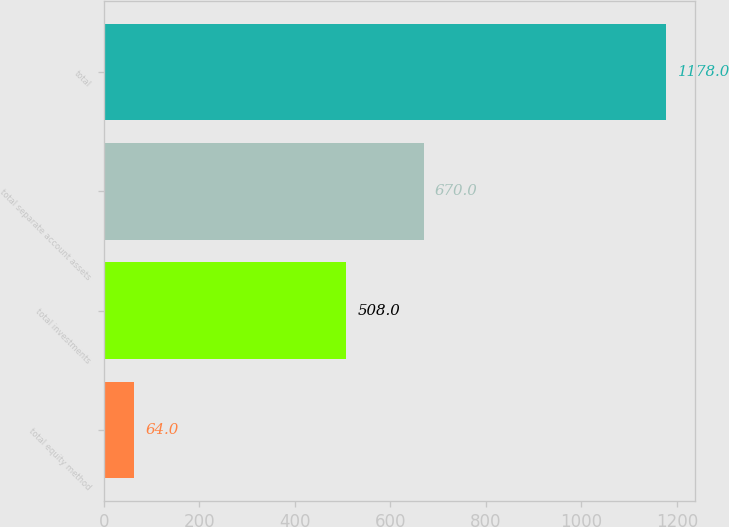<chart> <loc_0><loc_0><loc_500><loc_500><bar_chart><fcel>total equity method<fcel>total investments<fcel>total separate account assets<fcel>total<nl><fcel>64<fcel>508<fcel>670<fcel>1178<nl></chart> 